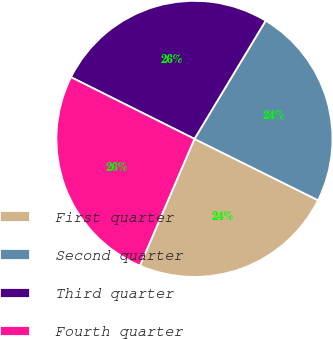Convert chart to OTSL. <chart><loc_0><loc_0><loc_500><loc_500><pie_chart><fcel>First quarter<fcel>Second quarter<fcel>Third quarter<fcel>Fourth quarter<nl><fcel>24.13%<fcel>23.7%<fcel>26.25%<fcel>25.91%<nl></chart> 